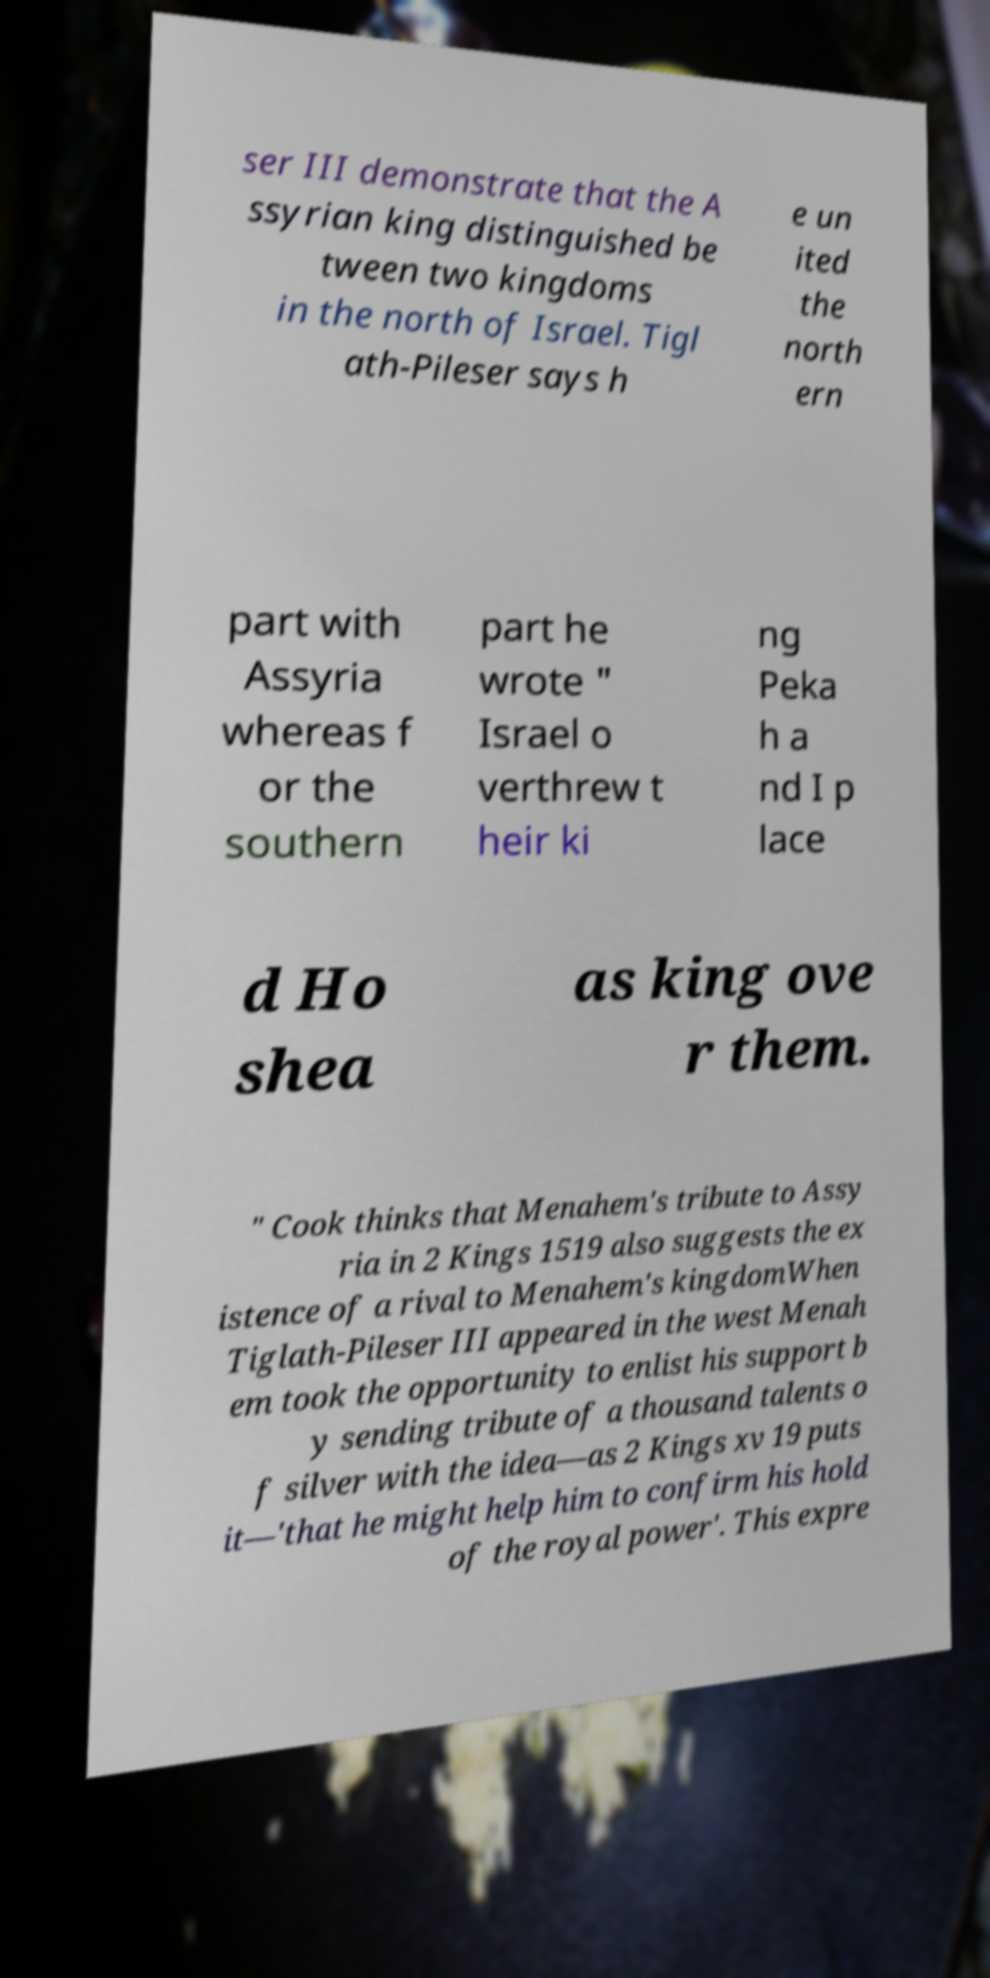There's text embedded in this image that I need extracted. Can you transcribe it verbatim? ser III demonstrate that the A ssyrian king distinguished be tween two kingdoms in the north of Israel. Tigl ath-Pileser says h e un ited the north ern part with Assyria whereas f or the southern part he wrote " Israel o verthrew t heir ki ng Peka h a nd I p lace d Ho shea as king ove r them. " Cook thinks that Menahem's tribute to Assy ria in 2 Kings 1519 also suggests the ex istence of a rival to Menahem's kingdomWhen Tiglath-Pileser III appeared in the west Menah em took the opportunity to enlist his support b y sending tribute of a thousand talents o f silver with the idea—as 2 Kings xv 19 puts it—'that he might help him to confirm his hold of the royal power'. This expre 